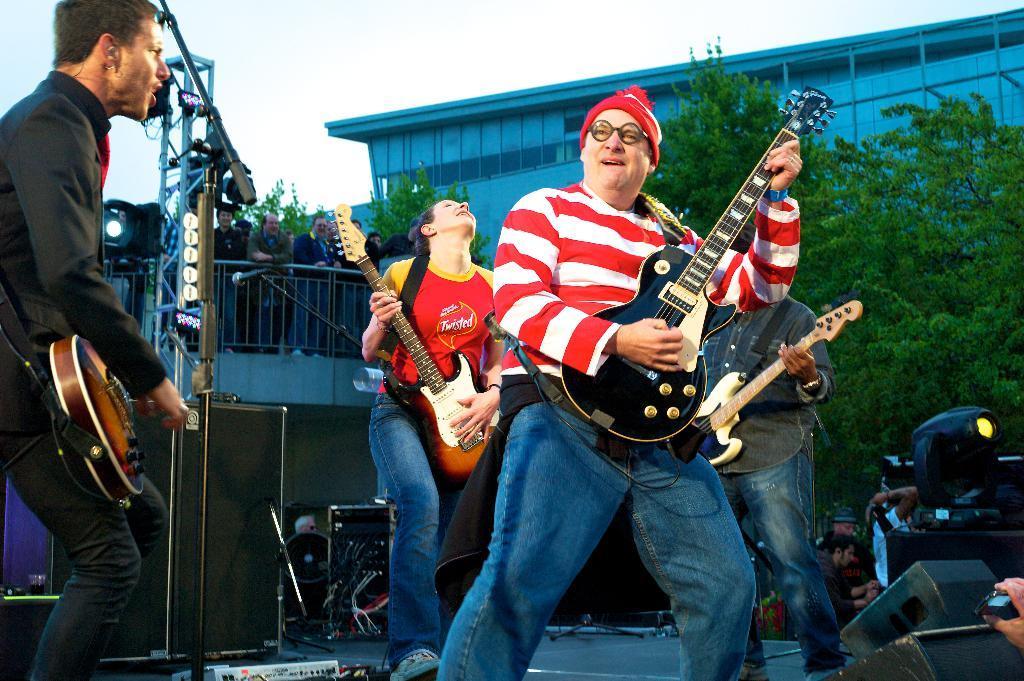Could you give a brief overview of what you see in this image? Here we can see a four people performing on a stage. They are playing a guitar and singing on a microphone. In the background we can see a few people standing over here and a tree on the right side. 